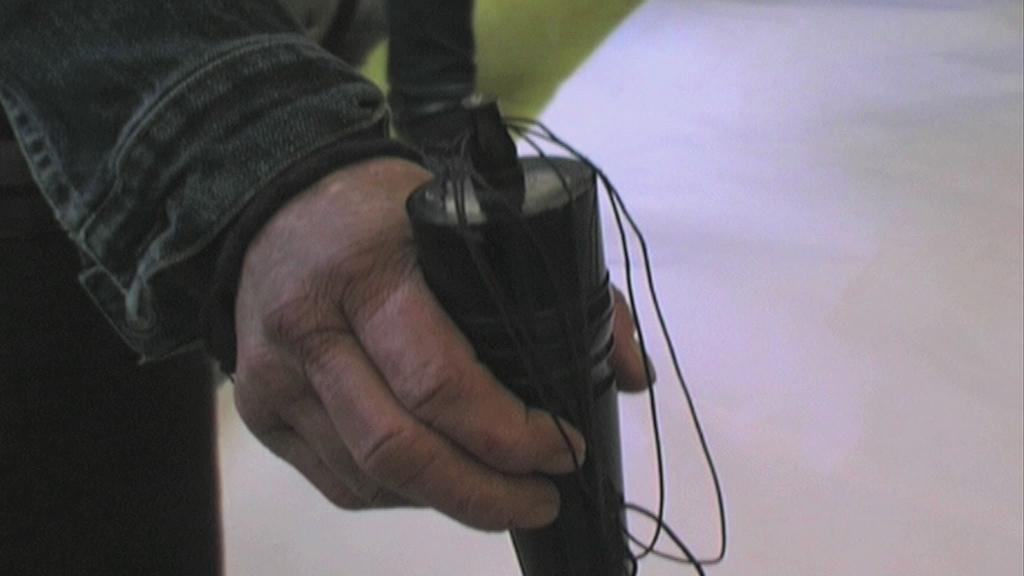Could you give a brief overview of what you see in this image? In this image, we can see a human hand is holding some object. Background we can see green and white color. 